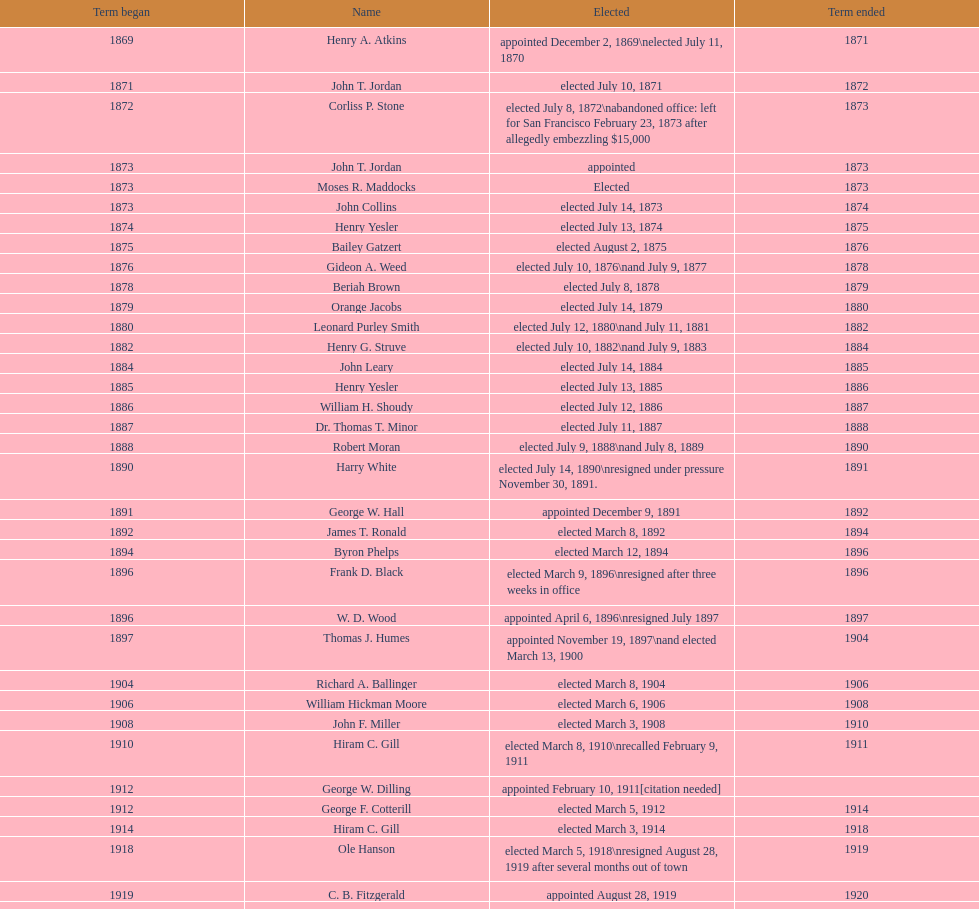Did charles royer hold office longer than paul schell? Yes. 